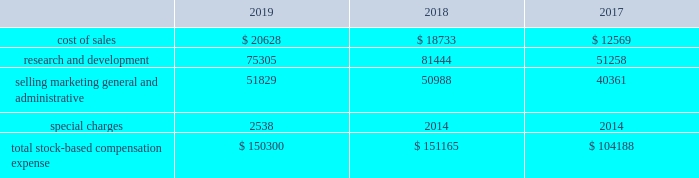Expected term 2014 the company uses historical employee exercise and option expiration data to estimate the expected term assumption for the black-scholes grant-date valuation .
The company believes that this historical data is currently the best estimate of the expected term of a new option , and that generally its employees exhibit similar exercise behavior .
Risk-free interest rate 2014 the yield on zero-coupon u.s .
Treasury securities for a period that is commensurate with the expected term assumption is used as the risk-free interest rate .
Expected dividend yield 2014 expected dividend yield is calculated by annualizing the cash dividend declared by the company 2019s board of directors for the current quarter and dividing that result by the closing stock price on the date of grant .
Until such time as the company 2019s board of directors declares a cash dividend for an amount that is different from the current quarter 2019s cash dividend , the current dividend will be used in deriving this assumption .
Cash dividends are not paid on options , restricted stock or restricted stock units .
In connection with the acquisition , the company granted restricted stock awards to replace outstanding restricted stock awards of linear employees .
These restricted stock awards entitle recipients to voting and nonforfeitable dividend rights from the date of grant .
Stock-based compensation expensexp p the amount of stock-based compensation expense recognized during a period is based on the value of the awards that are ultimately expected to vest .
Forfeitures are estimated at the time of grant and revised , if necessary , in subsequent periods if actual forfeitures differ from those estimates .
The term 201cforfeitures 201d is distinct from 201ccancellations 201d or 201cexpirations 201d and represents only the unvested portion of the surrendered stock-based award .
Based on an analysis of its historical forfeitures , the company has applied an annual forfeitureff rate of 5.0% ( 5.0 % ) to all unvested stock-based awards as of november 2 , 2019 .
This analysis will be re-evaluated quarterly and the forfeiture rate will be adjusted as necessary .
Ultimately , the actual expense recognized over the vesting period will only be for those awards that vest .
Total stock-based compensation expense recognized is as follows: .
As of november 2 , 2019 and november 3 , 2018 , the company capitalized $ 6.8 million and $ 7.1 million , respectively , of stock-based compensation in inventory .
Additional paid-in-capital ( apic ) pp poolp p ( ) the company adopted asu 2016-09 during fiscal 2018 .
Asu 2016-09 eliminated the apic pool and requires that excess tax benefits and tax deficiencies be recorded in the income statement when awards are settled .
As a result of this adoption the company recorded total excess tax benefits of $ 28.7 million and $ 26.2 million in fiscal 2019 and fiscal 2018 , respectively , from its stock-based compensation payments within income tax expense in its consolidated statements of income .
For fiscal 2017 , the apic pool represented the excess tax benefits related to stock-based compensation that were available to absorb future tax deficiencies .
If the amount of future tax deficiencies was greater than the available apic pool , the company recorded the excess as income tax expense in its consolidated statements of income .
For fiscal 2017 , the company had a sufficient apic pool to cover any tax deficiencies recorded and as a result , these deficiencies did not affect its results of operations .
Analog devices , inc .
Notes to consolidated financial statements 2014 ( continued ) .
What is the growth rate in the r&d in 2019? 
Computations: ((75305 - 81444) / 81444)
Answer: -0.07538. 